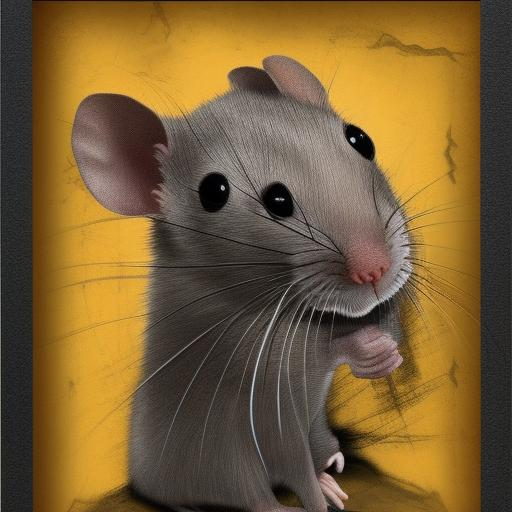What emotional tone does the image convey and why? The image conveys a sense of curiosity and slight apprehension. The mouse's large, glossy eyes and the way it holds its paws close to its mouth give it an expression of cautious interest, while the cracked yellow background adds a subtle tension to the scene. 